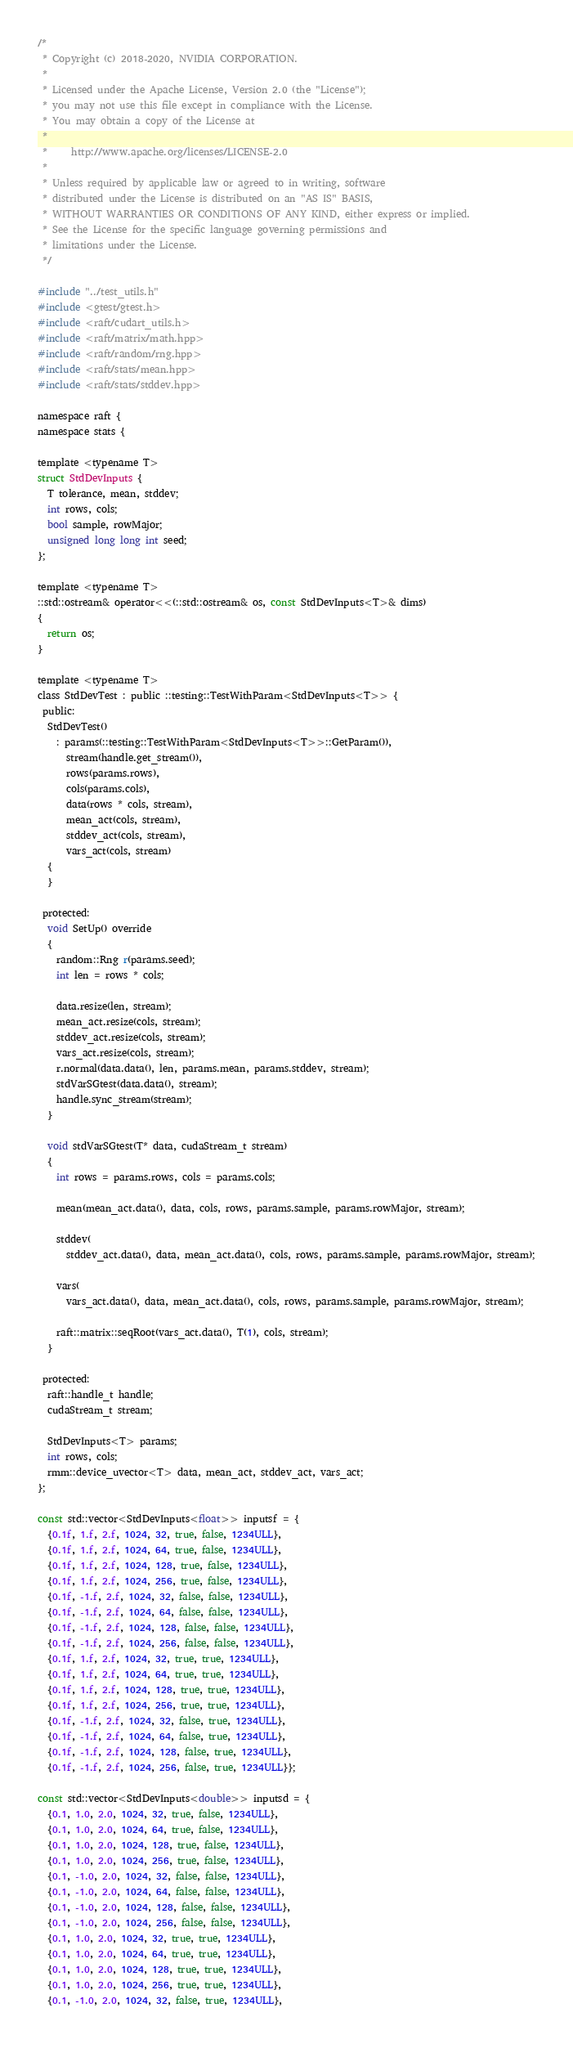<code> <loc_0><loc_0><loc_500><loc_500><_Cuda_>/*
 * Copyright (c) 2018-2020, NVIDIA CORPORATION.
 *
 * Licensed under the Apache License, Version 2.0 (the "License");
 * you may not use this file except in compliance with the License.
 * You may obtain a copy of the License at
 *
 *     http://www.apache.org/licenses/LICENSE-2.0
 *
 * Unless required by applicable law or agreed to in writing, software
 * distributed under the License is distributed on an "AS IS" BASIS,
 * WITHOUT WARRANTIES OR CONDITIONS OF ANY KIND, either express or implied.
 * See the License for the specific language governing permissions and
 * limitations under the License.
 */

#include "../test_utils.h"
#include <gtest/gtest.h>
#include <raft/cudart_utils.h>
#include <raft/matrix/math.hpp>
#include <raft/random/rng.hpp>
#include <raft/stats/mean.hpp>
#include <raft/stats/stddev.hpp>

namespace raft {
namespace stats {

template <typename T>
struct StdDevInputs {
  T tolerance, mean, stddev;
  int rows, cols;
  bool sample, rowMajor;
  unsigned long long int seed;
};

template <typename T>
::std::ostream& operator<<(::std::ostream& os, const StdDevInputs<T>& dims)
{
  return os;
}

template <typename T>
class StdDevTest : public ::testing::TestWithParam<StdDevInputs<T>> {
 public:
  StdDevTest()
    : params(::testing::TestWithParam<StdDevInputs<T>>::GetParam()),
      stream(handle.get_stream()),
      rows(params.rows),
      cols(params.cols),
      data(rows * cols, stream),
      mean_act(cols, stream),
      stddev_act(cols, stream),
      vars_act(cols, stream)
  {
  }

 protected:
  void SetUp() override
  {
    random::Rng r(params.seed);
    int len = rows * cols;

    data.resize(len, stream);
    mean_act.resize(cols, stream);
    stddev_act.resize(cols, stream);
    vars_act.resize(cols, stream);
    r.normal(data.data(), len, params.mean, params.stddev, stream);
    stdVarSGtest(data.data(), stream);
    handle.sync_stream(stream);
  }

  void stdVarSGtest(T* data, cudaStream_t stream)
  {
    int rows = params.rows, cols = params.cols;

    mean(mean_act.data(), data, cols, rows, params.sample, params.rowMajor, stream);

    stddev(
      stddev_act.data(), data, mean_act.data(), cols, rows, params.sample, params.rowMajor, stream);

    vars(
      vars_act.data(), data, mean_act.data(), cols, rows, params.sample, params.rowMajor, stream);

    raft::matrix::seqRoot(vars_act.data(), T(1), cols, stream);
  }

 protected:
  raft::handle_t handle;
  cudaStream_t stream;

  StdDevInputs<T> params;
  int rows, cols;
  rmm::device_uvector<T> data, mean_act, stddev_act, vars_act;
};

const std::vector<StdDevInputs<float>> inputsf = {
  {0.1f, 1.f, 2.f, 1024, 32, true, false, 1234ULL},
  {0.1f, 1.f, 2.f, 1024, 64, true, false, 1234ULL},
  {0.1f, 1.f, 2.f, 1024, 128, true, false, 1234ULL},
  {0.1f, 1.f, 2.f, 1024, 256, true, false, 1234ULL},
  {0.1f, -1.f, 2.f, 1024, 32, false, false, 1234ULL},
  {0.1f, -1.f, 2.f, 1024, 64, false, false, 1234ULL},
  {0.1f, -1.f, 2.f, 1024, 128, false, false, 1234ULL},
  {0.1f, -1.f, 2.f, 1024, 256, false, false, 1234ULL},
  {0.1f, 1.f, 2.f, 1024, 32, true, true, 1234ULL},
  {0.1f, 1.f, 2.f, 1024, 64, true, true, 1234ULL},
  {0.1f, 1.f, 2.f, 1024, 128, true, true, 1234ULL},
  {0.1f, 1.f, 2.f, 1024, 256, true, true, 1234ULL},
  {0.1f, -1.f, 2.f, 1024, 32, false, true, 1234ULL},
  {0.1f, -1.f, 2.f, 1024, 64, false, true, 1234ULL},
  {0.1f, -1.f, 2.f, 1024, 128, false, true, 1234ULL},
  {0.1f, -1.f, 2.f, 1024, 256, false, true, 1234ULL}};

const std::vector<StdDevInputs<double>> inputsd = {
  {0.1, 1.0, 2.0, 1024, 32, true, false, 1234ULL},
  {0.1, 1.0, 2.0, 1024, 64, true, false, 1234ULL},
  {0.1, 1.0, 2.0, 1024, 128, true, false, 1234ULL},
  {0.1, 1.0, 2.0, 1024, 256, true, false, 1234ULL},
  {0.1, -1.0, 2.0, 1024, 32, false, false, 1234ULL},
  {0.1, -1.0, 2.0, 1024, 64, false, false, 1234ULL},
  {0.1, -1.0, 2.0, 1024, 128, false, false, 1234ULL},
  {0.1, -1.0, 2.0, 1024, 256, false, false, 1234ULL},
  {0.1, 1.0, 2.0, 1024, 32, true, true, 1234ULL},
  {0.1, 1.0, 2.0, 1024, 64, true, true, 1234ULL},
  {0.1, 1.0, 2.0, 1024, 128, true, true, 1234ULL},
  {0.1, 1.0, 2.0, 1024, 256, true, true, 1234ULL},
  {0.1, -1.0, 2.0, 1024, 32, false, true, 1234ULL},</code> 